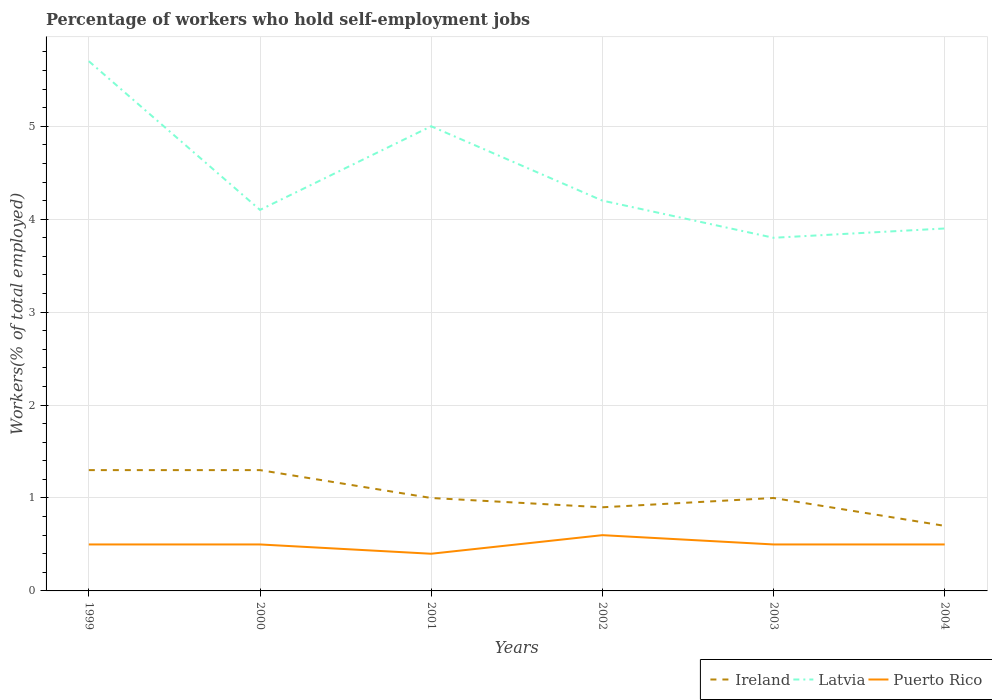Across all years, what is the maximum percentage of self-employed workers in Latvia?
Your answer should be very brief. 3.8. In which year was the percentage of self-employed workers in Latvia maximum?
Provide a succinct answer. 2003. What is the difference between the highest and the second highest percentage of self-employed workers in Latvia?
Keep it short and to the point. 1.9. Is the percentage of self-employed workers in Latvia strictly greater than the percentage of self-employed workers in Puerto Rico over the years?
Give a very brief answer. No. How many lines are there?
Ensure brevity in your answer.  3. Does the graph contain grids?
Offer a very short reply. Yes. How are the legend labels stacked?
Your answer should be very brief. Horizontal. What is the title of the graph?
Make the answer very short. Percentage of workers who hold self-employment jobs. Does "Kenya" appear as one of the legend labels in the graph?
Provide a succinct answer. No. What is the label or title of the Y-axis?
Keep it short and to the point. Workers(% of total employed). What is the Workers(% of total employed) of Ireland in 1999?
Offer a very short reply. 1.3. What is the Workers(% of total employed) of Latvia in 1999?
Ensure brevity in your answer.  5.7. What is the Workers(% of total employed) of Ireland in 2000?
Offer a terse response. 1.3. What is the Workers(% of total employed) in Latvia in 2000?
Offer a very short reply. 4.1. What is the Workers(% of total employed) in Puerto Rico in 2001?
Ensure brevity in your answer.  0.4. What is the Workers(% of total employed) in Ireland in 2002?
Your answer should be very brief. 0.9. What is the Workers(% of total employed) of Latvia in 2002?
Ensure brevity in your answer.  4.2. What is the Workers(% of total employed) of Puerto Rico in 2002?
Your response must be concise. 0.6. What is the Workers(% of total employed) in Latvia in 2003?
Ensure brevity in your answer.  3.8. What is the Workers(% of total employed) of Puerto Rico in 2003?
Your answer should be very brief. 0.5. What is the Workers(% of total employed) of Ireland in 2004?
Offer a very short reply. 0.7. What is the Workers(% of total employed) of Latvia in 2004?
Your answer should be compact. 3.9. Across all years, what is the maximum Workers(% of total employed) in Ireland?
Make the answer very short. 1.3. Across all years, what is the maximum Workers(% of total employed) in Latvia?
Provide a succinct answer. 5.7. Across all years, what is the maximum Workers(% of total employed) in Puerto Rico?
Ensure brevity in your answer.  0.6. Across all years, what is the minimum Workers(% of total employed) of Ireland?
Provide a succinct answer. 0.7. Across all years, what is the minimum Workers(% of total employed) in Latvia?
Offer a terse response. 3.8. Across all years, what is the minimum Workers(% of total employed) in Puerto Rico?
Offer a terse response. 0.4. What is the total Workers(% of total employed) of Latvia in the graph?
Provide a succinct answer. 26.7. What is the total Workers(% of total employed) in Puerto Rico in the graph?
Your response must be concise. 3. What is the difference between the Workers(% of total employed) of Ireland in 1999 and that in 2000?
Provide a succinct answer. 0. What is the difference between the Workers(% of total employed) in Latvia in 1999 and that in 2000?
Offer a terse response. 1.6. What is the difference between the Workers(% of total employed) of Ireland in 1999 and that in 2001?
Your response must be concise. 0.3. What is the difference between the Workers(% of total employed) of Latvia in 1999 and that in 2001?
Your response must be concise. 0.7. What is the difference between the Workers(% of total employed) of Puerto Rico in 1999 and that in 2001?
Provide a short and direct response. 0.1. What is the difference between the Workers(% of total employed) of Ireland in 1999 and that in 2002?
Provide a succinct answer. 0.4. What is the difference between the Workers(% of total employed) of Latvia in 1999 and that in 2002?
Make the answer very short. 1.5. What is the difference between the Workers(% of total employed) in Ireland in 1999 and that in 2004?
Offer a terse response. 0.6. What is the difference between the Workers(% of total employed) of Latvia in 2000 and that in 2001?
Make the answer very short. -0.9. What is the difference between the Workers(% of total employed) in Puerto Rico in 2000 and that in 2001?
Your answer should be compact. 0.1. What is the difference between the Workers(% of total employed) in Puerto Rico in 2000 and that in 2002?
Your answer should be very brief. -0.1. What is the difference between the Workers(% of total employed) in Latvia in 2000 and that in 2004?
Offer a very short reply. 0.2. What is the difference between the Workers(% of total employed) of Puerto Rico in 2000 and that in 2004?
Provide a short and direct response. 0. What is the difference between the Workers(% of total employed) of Ireland in 2001 and that in 2002?
Provide a short and direct response. 0.1. What is the difference between the Workers(% of total employed) in Puerto Rico in 2001 and that in 2002?
Make the answer very short. -0.2. What is the difference between the Workers(% of total employed) in Puerto Rico in 2001 and that in 2003?
Make the answer very short. -0.1. What is the difference between the Workers(% of total employed) of Ireland in 2001 and that in 2004?
Your answer should be very brief. 0.3. What is the difference between the Workers(% of total employed) in Latvia in 2001 and that in 2004?
Your response must be concise. 1.1. What is the difference between the Workers(% of total employed) of Ireland in 2002 and that in 2003?
Your answer should be compact. -0.1. What is the difference between the Workers(% of total employed) of Puerto Rico in 2002 and that in 2003?
Keep it short and to the point. 0.1. What is the difference between the Workers(% of total employed) of Ireland in 2002 and that in 2004?
Your response must be concise. 0.2. What is the difference between the Workers(% of total employed) of Latvia in 2002 and that in 2004?
Your answer should be very brief. 0.3. What is the difference between the Workers(% of total employed) in Ireland in 1999 and the Workers(% of total employed) in Puerto Rico in 2001?
Provide a short and direct response. 0.9. What is the difference between the Workers(% of total employed) in Latvia in 1999 and the Workers(% of total employed) in Puerto Rico in 2002?
Offer a very short reply. 5.1. What is the difference between the Workers(% of total employed) of Ireland in 1999 and the Workers(% of total employed) of Puerto Rico in 2003?
Give a very brief answer. 0.8. What is the difference between the Workers(% of total employed) of Ireland in 1999 and the Workers(% of total employed) of Latvia in 2004?
Your answer should be very brief. -2.6. What is the difference between the Workers(% of total employed) of Ireland in 1999 and the Workers(% of total employed) of Puerto Rico in 2004?
Your answer should be compact. 0.8. What is the difference between the Workers(% of total employed) in Latvia in 1999 and the Workers(% of total employed) in Puerto Rico in 2004?
Offer a very short reply. 5.2. What is the difference between the Workers(% of total employed) in Ireland in 2000 and the Workers(% of total employed) in Latvia in 2001?
Provide a short and direct response. -3.7. What is the difference between the Workers(% of total employed) in Ireland in 2000 and the Workers(% of total employed) in Puerto Rico in 2001?
Offer a very short reply. 0.9. What is the difference between the Workers(% of total employed) of Latvia in 2000 and the Workers(% of total employed) of Puerto Rico in 2001?
Make the answer very short. 3.7. What is the difference between the Workers(% of total employed) in Ireland in 2000 and the Workers(% of total employed) in Latvia in 2002?
Ensure brevity in your answer.  -2.9. What is the difference between the Workers(% of total employed) of Ireland in 2000 and the Workers(% of total employed) of Puerto Rico in 2002?
Provide a succinct answer. 0.7. What is the difference between the Workers(% of total employed) of Ireland in 2000 and the Workers(% of total employed) of Latvia in 2003?
Ensure brevity in your answer.  -2.5. What is the difference between the Workers(% of total employed) in Latvia in 2000 and the Workers(% of total employed) in Puerto Rico in 2003?
Make the answer very short. 3.6. What is the difference between the Workers(% of total employed) in Latvia in 2000 and the Workers(% of total employed) in Puerto Rico in 2004?
Offer a terse response. 3.6. What is the difference between the Workers(% of total employed) in Ireland in 2001 and the Workers(% of total employed) in Puerto Rico in 2002?
Ensure brevity in your answer.  0.4. What is the difference between the Workers(% of total employed) in Latvia in 2001 and the Workers(% of total employed) in Puerto Rico in 2003?
Offer a terse response. 4.5. What is the difference between the Workers(% of total employed) in Ireland in 2002 and the Workers(% of total employed) in Latvia in 2003?
Provide a succinct answer. -2.9. What is the difference between the Workers(% of total employed) of Ireland in 2002 and the Workers(% of total employed) of Puerto Rico in 2003?
Your response must be concise. 0.4. What is the difference between the Workers(% of total employed) of Ireland in 2002 and the Workers(% of total employed) of Latvia in 2004?
Your response must be concise. -3. What is the difference between the Workers(% of total employed) in Ireland in 2002 and the Workers(% of total employed) in Puerto Rico in 2004?
Offer a terse response. 0.4. What is the difference between the Workers(% of total employed) in Ireland in 2003 and the Workers(% of total employed) in Latvia in 2004?
Provide a succinct answer. -2.9. What is the difference between the Workers(% of total employed) in Ireland in 2003 and the Workers(% of total employed) in Puerto Rico in 2004?
Offer a terse response. 0.5. What is the average Workers(% of total employed) in Ireland per year?
Offer a terse response. 1.03. What is the average Workers(% of total employed) of Latvia per year?
Offer a terse response. 4.45. What is the average Workers(% of total employed) in Puerto Rico per year?
Give a very brief answer. 0.5. In the year 2000, what is the difference between the Workers(% of total employed) in Ireland and Workers(% of total employed) in Puerto Rico?
Provide a succinct answer. 0.8. In the year 2001, what is the difference between the Workers(% of total employed) of Ireland and Workers(% of total employed) of Latvia?
Your answer should be compact. -4. In the year 2001, what is the difference between the Workers(% of total employed) of Ireland and Workers(% of total employed) of Puerto Rico?
Your response must be concise. 0.6. In the year 2001, what is the difference between the Workers(% of total employed) of Latvia and Workers(% of total employed) of Puerto Rico?
Make the answer very short. 4.6. In the year 2003, what is the difference between the Workers(% of total employed) of Ireland and Workers(% of total employed) of Latvia?
Ensure brevity in your answer.  -2.8. In the year 2003, what is the difference between the Workers(% of total employed) of Latvia and Workers(% of total employed) of Puerto Rico?
Make the answer very short. 3.3. In the year 2004, what is the difference between the Workers(% of total employed) of Ireland and Workers(% of total employed) of Latvia?
Your answer should be compact. -3.2. In the year 2004, what is the difference between the Workers(% of total employed) in Ireland and Workers(% of total employed) in Puerto Rico?
Provide a succinct answer. 0.2. What is the ratio of the Workers(% of total employed) in Latvia in 1999 to that in 2000?
Provide a succinct answer. 1.39. What is the ratio of the Workers(% of total employed) of Puerto Rico in 1999 to that in 2000?
Make the answer very short. 1. What is the ratio of the Workers(% of total employed) of Latvia in 1999 to that in 2001?
Ensure brevity in your answer.  1.14. What is the ratio of the Workers(% of total employed) of Ireland in 1999 to that in 2002?
Provide a succinct answer. 1.44. What is the ratio of the Workers(% of total employed) in Latvia in 1999 to that in 2002?
Offer a terse response. 1.36. What is the ratio of the Workers(% of total employed) in Ireland in 1999 to that in 2004?
Provide a short and direct response. 1.86. What is the ratio of the Workers(% of total employed) in Latvia in 1999 to that in 2004?
Provide a succinct answer. 1.46. What is the ratio of the Workers(% of total employed) in Puerto Rico in 1999 to that in 2004?
Your response must be concise. 1. What is the ratio of the Workers(% of total employed) in Latvia in 2000 to that in 2001?
Keep it short and to the point. 0.82. What is the ratio of the Workers(% of total employed) of Ireland in 2000 to that in 2002?
Your answer should be compact. 1.44. What is the ratio of the Workers(% of total employed) in Latvia in 2000 to that in 2002?
Your response must be concise. 0.98. What is the ratio of the Workers(% of total employed) in Puerto Rico in 2000 to that in 2002?
Offer a terse response. 0.83. What is the ratio of the Workers(% of total employed) of Ireland in 2000 to that in 2003?
Keep it short and to the point. 1.3. What is the ratio of the Workers(% of total employed) in Latvia in 2000 to that in 2003?
Make the answer very short. 1.08. What is the ratio of the Workers(% of total employed) of Puerto Rico in 2000 to that in 2003?
Offer a terse response. 1. What is the ratio of the Workers(% of total employed) of Ireland in 2000 to that in 2004?
Ensure brevity in your answer.  1.86. What is the ratio of the Workers(% of total employed) of Latvia in 2000 to that in 2004?
Your answer should be compact. 1.05. What is the ratio of the Workers(% of total employed) of Puerto Rico in 2000 to that in 2004?
Provide a succinct answer. 1. What is the ratio of the Workers(% of total employed) of Ireland in 2001 to that in 2002?
Your answer should be compact. 1.11. What is the ratio of the Workers(% of total employed) of Latvia in 2001 to that in 2002?
Keep it short and to the point. 1.19. What is the ratio of the Workers(% of total employed) of Puerto Rico in 2001 to that in 2002?
Offer a terse response. 0.67. What is the ratio of the Workers(% of total employed) in Latvia in 2001 to that in 2003?
Ensure brevity in your answer.  1.32. What is the ratio of the Workers(% of total employed) of Ireland in 2001 to that in 2004?
Make the answer very short. 1.43. What is the ratio of the Workers(% of total employed) in Latvia in 2001 to that in 2004?
Give a very brief answer. 1.28. What is the ratio of the Workers(% of total employed) in Ireland in 2002 to that in 2003?
Provide a succinct answer. 0.9. What is the ratio of the Workers(% of total employed) in Latvia in 2002 to that in 2003?
Offer a terse response. 1.11. What is the ratio of the Workers(% of total employed) of Latvia in 2002 to that in 2004?
Give a very brief answer. 1.08. What is the ratio of the Workers(% of total employed) in Puerto Rico in 2002 to that in 2004?
Your answer should be compact. 1.2. What is the ratio of the Workers(% of total employed) of Ireland in 2003 to that in 2004?
Ensure brevity in your answer.  1.43. What is the ratio of the Workers(% of total employed) of Latvia in 2003 to that in 2004?
Give a very brief answer. 0.97. What is the difference between the highest and the second highest Workers(% of total employed) of Puerto Rico?
Your answer should be very brief. 0.1. What is the difference between the highest and the lowest Workers(% of total employed) in Puerto Rico?
Offer a very short reply. 0.2. 